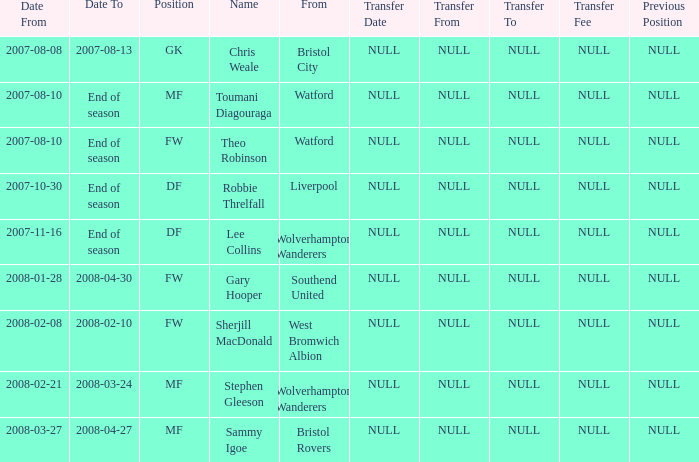When did toumani diagouraga, a midfielder, start playing? 2007-08-10. 